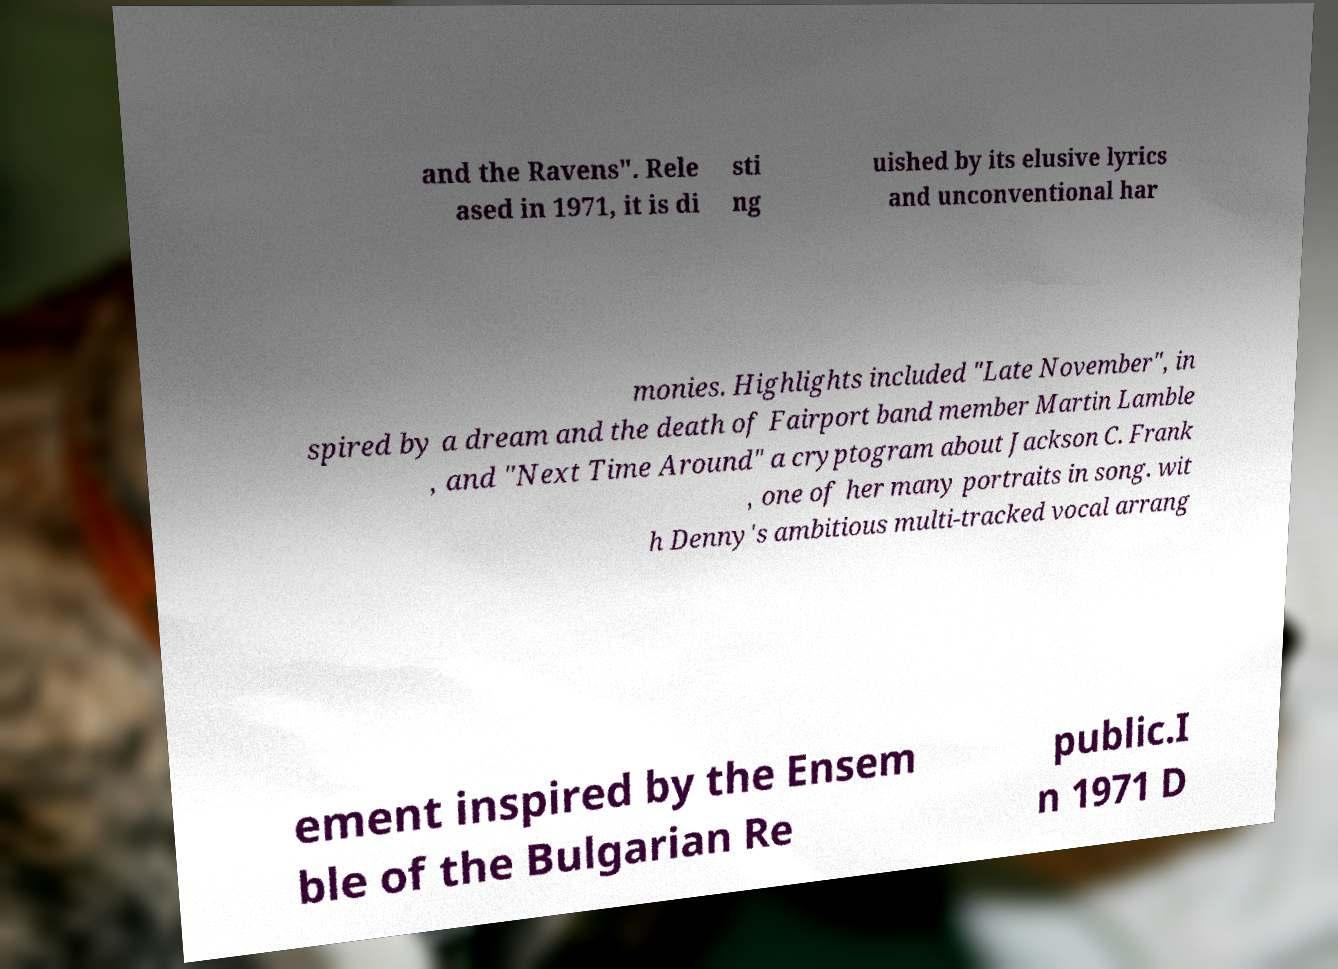Please read and relay the text visible in this image. What does it say? and the Ravens". Rele ased in 1971, it is di sti ng uished by its elusive lyrics and unconventional har monies. Highlights included "Late November", in spired by a dream and the death of Fairport band member Martin Lamble , and "Next Time Around" a cryptogram about Jackson C. Frank , one of her many portraits in song. wit h Denny's ambitious multi-tracked vocal arrang ement inspired by the Ensem ble of the Bulgarian Re public.I n 1971 D 